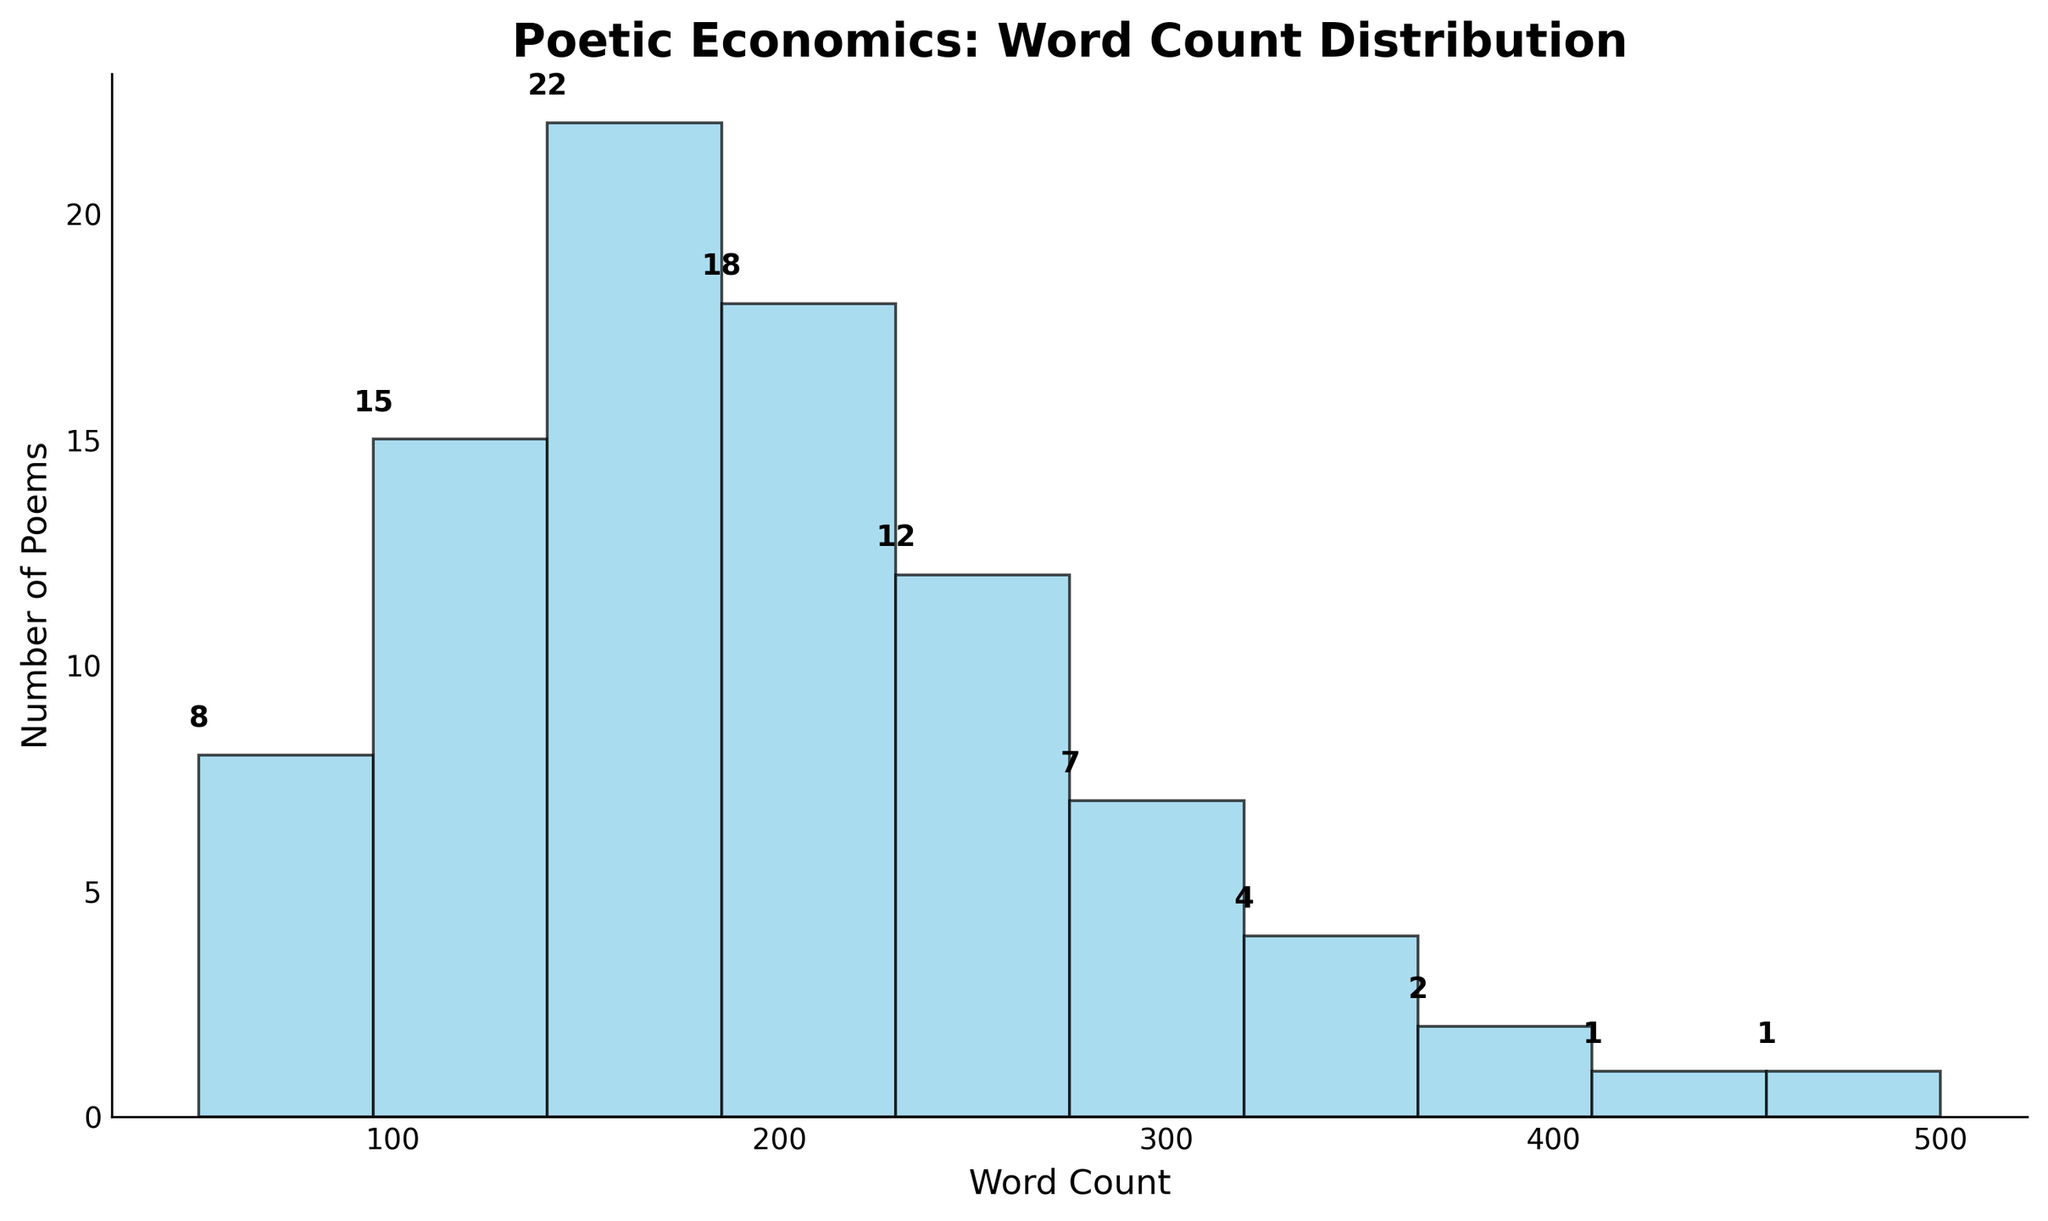What's the title of the figure? The title on the top of the figure is usually large and bold, making it easy to identify.
Answer: Poetic Economics: Word Count Distribution How many poems have a word count between 101 and 150? Look at the height of the bar corresponding to the word count range of 101-150 and read the numeric label on top.
Answer: 22 What is the range with the smallest number of poems, and how many poems are in that range? Find the bar with the lowest height and read its word count range and the numeric label above it.
Answer: 451-500, 1 How many poems have a word count of 200 or more? Sum the numbers of poems from the bins 201-250 to 451-500.
Answer: 27 What is the most common word count range for the poems? Identify the tallest bar in the histogram and read its word count range.
Answer: 101-150 How many poems in total are shown in the histogram? Add up all the numbers of poems from each range.
Answer: 90 What is the difference in the number of poems between the ranges 0-50 and 51-100? Subtract the number of poems in the range 0-50 from the number in the range 51-100.
Answer: 7 Which range has the second highest number of poems, and how many are there? Identify the second tallest bar and read its word count range and the number on top.
Answer: 151-200, 18 What is the average number of poems per word count range? Total the number of poems (90) and divide by the number of ranges (10).
Answer: 9 In which word count range does the number of poems transition from double digits to single digits? Find the range where the number of poems first drops from two digits to a lower single-digit in the histogram.
Answer: 201-250 